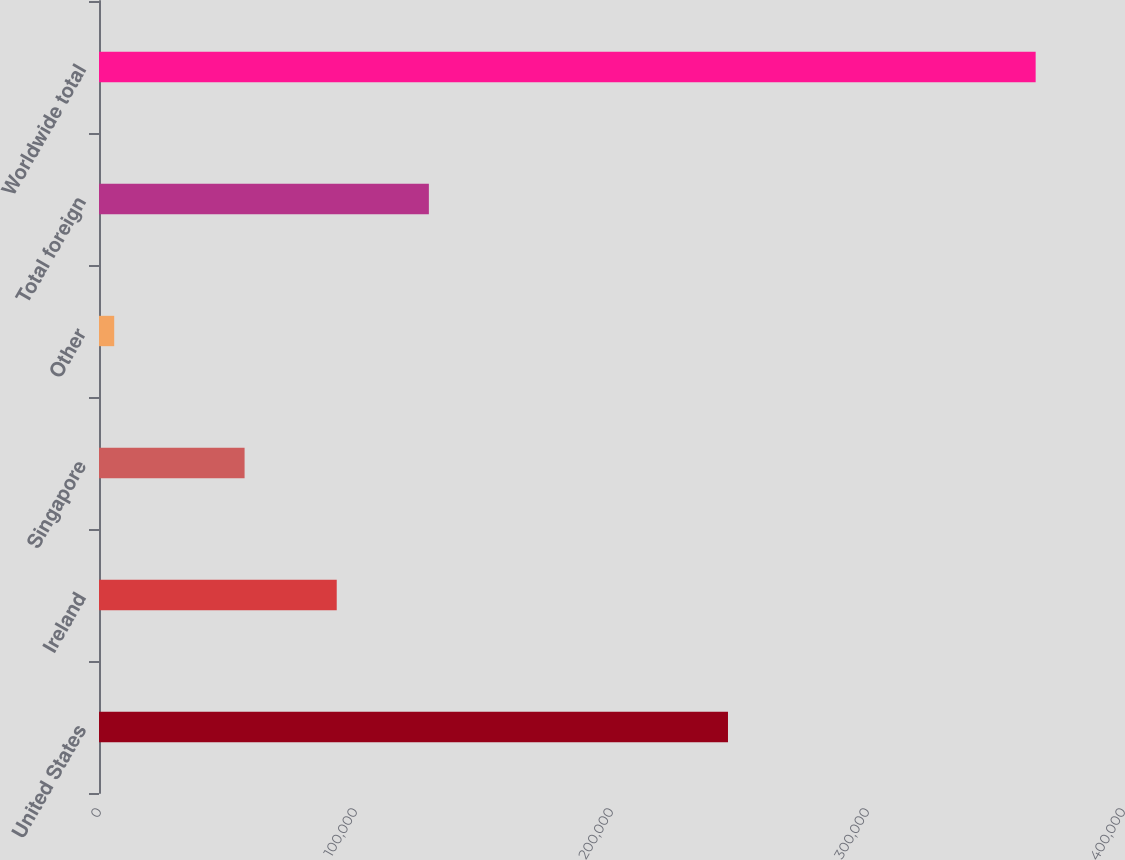Convert chart to OTSL. <chart><loc_0><loc_0><loc_500><loc_500><bar_chart><fcel>United States<fcel>Ireland<fcel>Singapore<fcel>Other<fcel>Total foreign<fcel>Worldwide total<nl><fcel>245698<fcel>92862.6<fcel>56869<fcel>5942<fcel>128856<fcel>365878<nl></chart> 